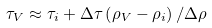<formula> <loc_0><loc_0><loc_500><loc_500>\tau _ { V } \approx \tau _ { i } + \Delta \tau \left ( \rho _ { V } - \rho _ { i } \right ) / \Delta \rho</formula> 